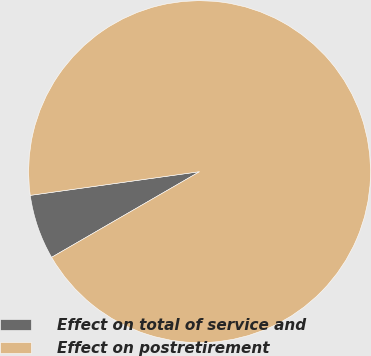<chart> <loc_0><loc_0><loc_500><loc_500><pie_chart><fcel>Effect on total of service and<fcel>Effect on postretirement<nl><fcel>6.14%<fcel>93.86%<nl></chart> 